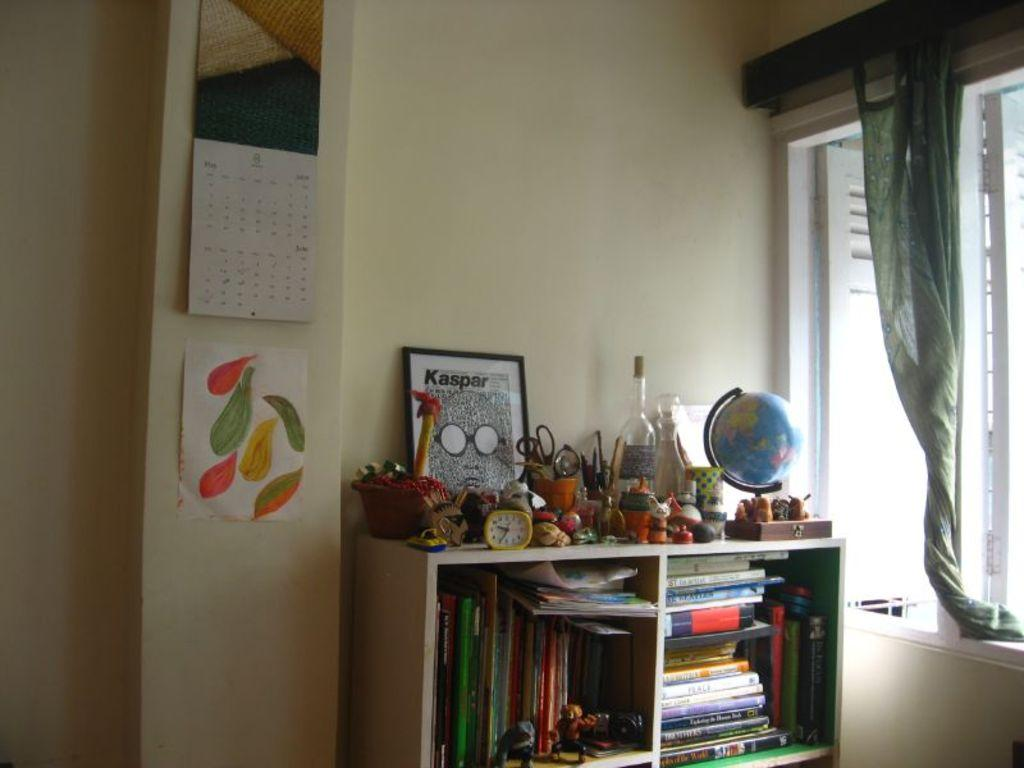Provide a one-sentence caption for the provided image. Room with a framed photo saying "Kaspar" and an empty bottle. 